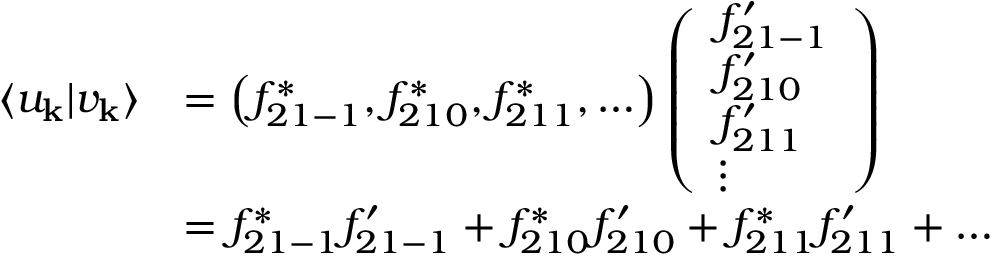<formula> <loc_0><loc_0><loc_500><loc_500>\begin{array} { r l } { \langle u _ { k } | v _ { k } \rangle } & { = \left ( f _ { 2 1 - 1 } ^ { * } , f _ { 2 1 0 } ^ { * } , f _ { 2 1 1 } ^ { * } , \dots \right ) \left ( \begin{array} { l } { f _ { 2 1 - 1 } ^ { \prime } } \\ { f _ { 2 1 0 } ^ { \prime } } \\ { f _ { 2 1 1 } ^ { \prime } } \\ { \vdots } \end{array} \right ) } \\ & { = f _ { 2 1 - 1 } ^ { * } f _ { 2 1 - 1 } ^ { \prime } + f _ { 2 1 0 } ^ { * } f _ { 2 1 0 } ^ { \prime } + f _ { 2 1 1 } ^ { * } f _ { 2 1 1 } ^ { \prime } + \dots } \end{array}</formula> 